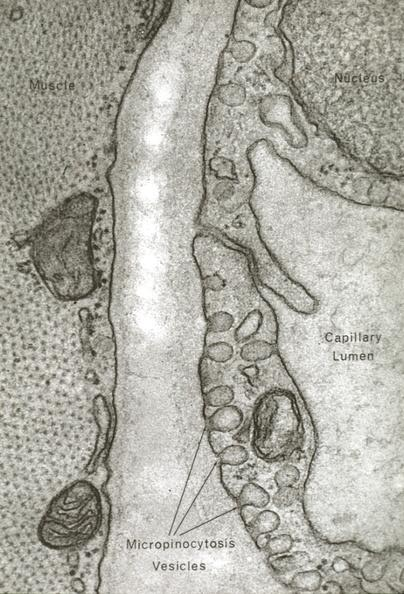what is present?
Answer the question using a single word or phrase. Cardiovascular 